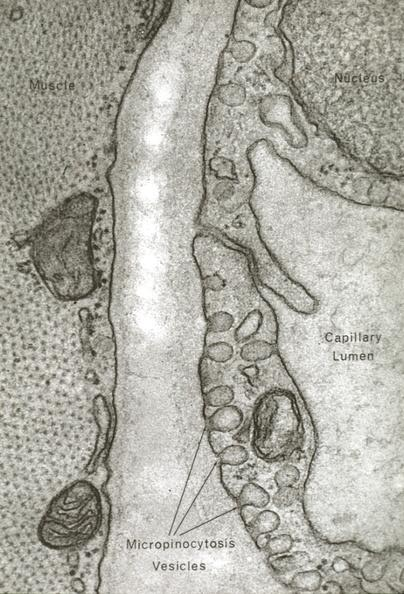what is present?
Answer the question using a single word or phrase. Cardiovascular 